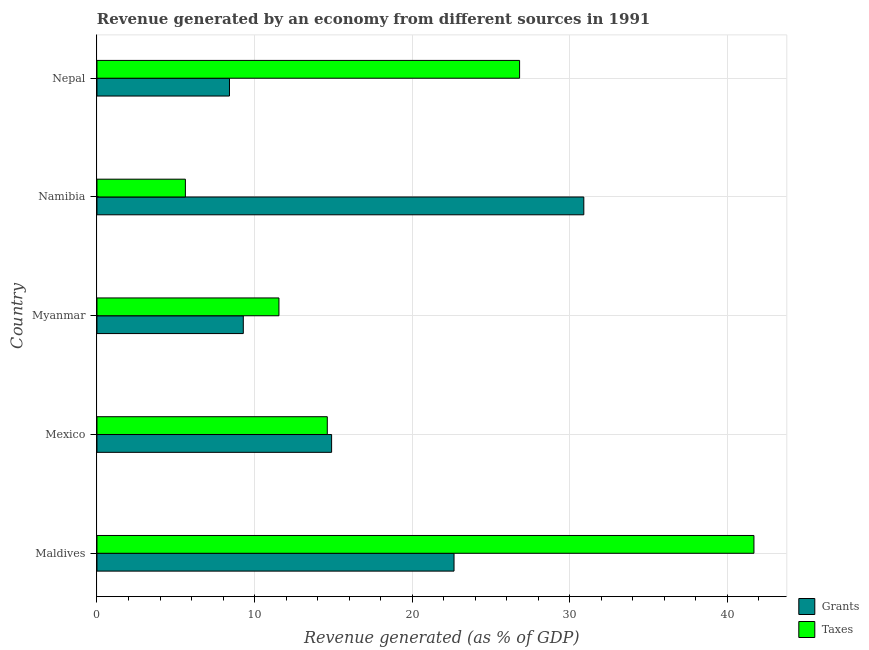How many different coloured bars are there?
Provide a succinct answer. 2. How many groups of bars are there?
Give a very brief answer. 5. How many bars are there on the 5th tick from the bottom?
Provide a succinct answer. 2. What is the label of the 1st group of bars from the top?
Make the answer very short. Nepal. What is the revenue generated by grants in Maldives?
Offer a terse response. 22.66. Across all countries, what is the maximum revenue generated by grants?
Your answer should be compact. 30.89. Across all countries, what is the minimum revenue generated by taxes?
Your response must be concise. 5.61. In which country was the revenue generated by grants maximum?
Offer a terse response. Namibia. In which country was the revenue generated by grants minimum?
Provide a short and direct response. Nepal. What is the total revenue generated by taxes in the graph?
Keep it short and to the point. 100.27. What is the difference between the revenue generated by taxes in Mexico and that in Namibia?
Provide a succinct answer. 9. What is the difference between the revenue generated by taxes in Mexico and the revenue generated by grants in Namibia?
Your response must be concise. -16.28. What is the average revenue generated by grants per country?
Your answer should be compact. 17.23. What is the difference between the revenue generated by taxes and revenue generated by grants in Myanmar?
Provide a succinct answer. 2.26. What is the ratio of the revenue generated by grants in Maldives to that in Myanmar?
Give a very brief answer. 2.44. What is the difference between the highest and the second highest revenue generated by grants?
Provide a succinct answer. 8.23. What is the difference between the highest and the lowest revenue generated by taxes?
Offer a very short reply. 36.07. In how many countries, is the revenue generated by grants greater than the average revenue generated by grants taken over all countries?
Offer a very short reply. 2. What does the 1st bar from the top in Mexico represents?
Make the answer very short. Taxes. What does the 2nd bar from the bottom in Mexico represents?
Give a very brief answer. Taxes. Are all the bars in the graph horizontal?
Offer a terse response. Yes. Does the graph contain grids?
Your answer should be very brief. Yes. How many legend labels are there?
Give a very brief answer. 2. What is the title of the graph?
Your response must be concise. Revenue generated by an economy from different sources in 1991. Does "Males" appear as one of the legend labels in the graph?
Keep it short and to the point. No. What is the label or title of the X-axis?
Offer a terse response. Revenue generated (as % of GDP). What is the label or title of the Y-axis?
Your response must be concise. Country. What is the Revenue generated (as % of GDP) of Grants in Maldives?
Your answer should be very brief. 22.66. What is the Revenue generated (as % of GDP) in Taxes in Maldives?
Provide a succinct answer. 41.68. What is the Revenue generated (as % of GDP) of Grants in Mexico?
Provide a succinct answer. 14.89. What is the Revenue generated (as % of GDP) of Taxes in Mexico?
Ensure brevity in your answer.  14.61. What is the Revenue generated (as % of GDP) in Grants in Myanmar?
Keep it short and to the point. 9.28. What is the Revenue generated (as % of GDP) in Taxes in Myanmar?
Your answer should be compact. 11.55. What is the Revenue generated (as % of GDP) in Grants in Namibia?
Your answer should be compact. 30.89. What is the Revenue generated (as % of GDP) of Taxes in Namibia?
Your response must be concise. 5.61. What is the Revenue generated (as % of GDP) in Grants in Nepal?
Keep it short and to the point. 8.41. What is the Revenue generated (as % of GDP) in Taxes in Nepal?
Ensure brevity in your answer.  26.82. Across all countries, what is the maximum Revenue generated (as % of GDP) of Grants?
Offer a very short reply. 30.89. Across all countries, what is the maximum Revenue generated (as % of GDP) of Taxes?
Provide a succinct answer. 41.68. Across all countries, what is the minimum Revenue generated (as % of GDP) of Grants?
Offer a terse response. 8.41. Across all countries, what is the minimum Revenue generated (as % of GDP) of Taxes?
Provide a short and direct response. 5.61. What is the total Revenue generated (as % of GDP) in Grants in the graph?
Provide a succinct answer. 86.13. What is the total Revenue generated (as % of GDP) in Taxes in the graph?
Offer a terse response. 100.27. What is the difference between the Revenue generated (as % of GDP) in Grants in Maldives and that in Mexico?
Keep it short and to the point. 7.77. What is the difference between the Revenue generated (as % of GDP) of Taxes in Maldives and that in Mexico?
Keep it short and to the point. 27.07. What is the difference between the Revenue generated (as % of GDP) of Grants in Maldives and that in Myanmar?
Offer a terse response. 13.37. What is the difference between the Revenue generated (as % of GDP) in Taxes in Maldives and that in Myanmar?
Provide a succinct answer. 30.14. What is the difference between the Revenue generated (as % of GDP) in Grants in Maldives and that in Namibia?
Make the answer very short. -8.23. What is the difference between the Revenue generated (as % of GDP) of Taxes in Maldives and that in Namibia?
Your answer should be compact. 36.07. What is the difference between the Revenue generated (as % of GDP) of Grants in Maldives and that in Nepal?
Your answer should be compact. 14.25. What is the difference between the Revenue generated (as % of GDP) of Taxes in Maldives and that in Nepal?
Offer a terse response. 14.87. What is the difference between the Revenue generated (as % of GDP) of Grants in Mexico and that in Myanmar?
Your answer should be very brief. 5.6. What is the difference between the Revenue generated (as % of GDP) of Taxes in Mexico and that in Myanmar?
Make the answer very short. 3.07. What is the difference between the Revenue generated (as % of GDP) of Grants in Mexico and that in Namibia?
Keep it short and to the point. -16. What is the difference between the Revenue generated (as % of GDP) in Taxes in Mexico and that in Namibia?
Your answer should be very brief. 9. What is the difference between the Revenue generated (as % of GDP) of Grants in Mexico and that in Nepal?
Give a very brief answer. 6.48. What is the difference between the Revenue generated (as % of GDP) of Taxes in Mexico and that in Nepal?
Offer a terse response. -12.2. What is the difference between the Revenue generated (as % of GDP) in Grants in Myanmar and that in Namibia?
Ensure brevity in your answer.  -21.61. What is the difference between the Revenue generated (as % of GDP) of Taxes in Myanmar and that in Namibia?
Ensure brevity in your answer.  5.94. What is the difference between the Revenue generated (as % of GDP) in Grants in Myanmar and that in Nepal?
Offer a terse response. 0.88. What is the difference between the Revenue generated (as % of GDP) of Taxes in Myanmar and that in Nepal?
Offer a very short reply. -15.27. What is the difference between the Revenue generated (as % of GDP) of Grants in Namibia and that in Nepal?
Provide a short and direct response. 22.48. What is the difference between the Revenue generated (as % of GDP) of Taxes in Namibia and that in Nepal?
Offer a very short reply. -21.21. What is the difference between the Revenue generated (as % of GDP) in Grants in Maldives and the Revenue generated (as % of GDP) in Taxes in Mexico?
Offer a terse response. 8.04. What is the difference between the Revenue generated (as % of GDP) in Grants in Maldives and the Revenue generated (as % of GDP) in Taxes in Myanmar?
Your answer should be very brief. 11.11. What is the difference between the Revenue generated (as % of GDP) in Grants in Maldives and the Revenue generated (as % of GDP) in Taxes in Namibia?
Offer a very short reply. 17.05. What is the difference between the Revenue generated (as % of GDP) in Grants in Maldives and the Revenue generated (as % of GDP) in Taxes in Nepal?
Provide a succinct answer. -4.16. What is the difference between the Revenue generated (as % of GDP) in Grants in Mexico and the Revenue generated (as % of GDP) in Taxes in Myanmar?
Keep it short and to the point. 3.34. What is the difference between the Revenue generated (as % of GDP) of Grants in Mexico and the Revenue generated (as % of GDP) of Taxes in Namibia?
Provide a succinct answer. 9.28. What is the difference between the Revenue generated (as % of GDP) in Grants in Mexico and the Revenue generated (as % of GDP) in Taxes in Nepal?
Provide a short and direct response. -11.93. What is the difference between the Revenue generated (as % of GDP) of Grants in Myanmar and the Revenue generated (as % of GDP) of Taxes in Namibia?
Make the answer very short. 3.67. What is the difference between the Revenue generated (as % of GDP) in Grants in Myanmar and the Revenue generated (as % of GDP) in Taxes in Nepal?
Give a very brief answer. -17.53. What is the difference between the Revenue generated (as % of GDP) in Grants in Namibia and the Revenue generated (as % of GDP) in Taxes in Nepal?
Provide a succinct answer. 4.08. What is the average Revenue generated (as % of GDP) of Grants per country?
Make the answer very short. 17.23. What is the average Revenue generated (as % of GDP) in Taxes per country?
Your response must be concise. 20.05. What is the difference between the Revenue generated (as % of GDP) of Grants and Revenue generated (as % of GDP) of Taxes in Maldives?
Ensure brevity in your answer.  -19.03. What is the difference between the Revenue generated (as % of GDP) in Grants and Revenue generated (as % of GDP) in Taxes in Mexico?
Your answer should be very brief. 0.27. What is the difference between the Revenue generated (as % of GDP) in Grants and Revenue generated (as % of GDP) in Taxes in Myanmar?
Keep it short and to the point. -2.26. What is the difference between the Revenue generated (as % of GDP) in Grants and Revenue generated (as % of GDP) in Taxes in Namibia?
Your response must be concise. 25.28. What is the difference between the Revenue generated (as % of GDP) in Grants and Revenue generated (as % of GDP) in Taxes in Nepal?
Your answer should be very brief. -18.41. What is the ratio of the Revenue generated (as % of GDP) of Grants in Maldives to that in Mexico?
Offer a very short reply. 1.52. What is the ratio of the Revenue generated (as % of GDP) in Taxes in Maldives to that in Mexico?
Your answer should be very brief. 2.85. What is the ratio of the Revenue generated (as % of GDP) of Grants in Maldives to that in Myanmar?
Offer a very short reply. 2.44. What is the ratio of the Revenue generated (as % of GDP) in Taxes in Maldives to that in Myanmar?
Your response must be concise. 3.61. What is the ratio of the Revenue generated (as % of GDP) of Grants in Maldives to that in Namibia?
Ensure brevity in your answer.  0.73. What is the ratio of the Revenue generated (as % of GDP) of Taxes in Maldives to that in Namibia?
Provide a succinct answer. 7.43. What is the ratio of the Revenue generated (as % of GDP) of Grants in Maldives to that in Nepal?
Your response must be concise. 2.69. What is the ratio of the Revenue generated (as % of GDP) of Taxes in Maldives to that in Nepal?
Your answer should be very brief. 1.55. What is the ratio of the Revenue generated (as % of GDP) in Grants in Mexico to that in Myanmar?
Provide a succinct answer. 1.6. What is the ratio of the Revenue generated (as % of GDP) of Taxes in Mexico to that in Myanmar?
Provide a succinct answer. 1.27. What is the ratio of the Revenue generated (as % of GDP) of Grants in Mexico to that in Namibia?
Offer a terse response. 0.48. What is the ratio of the Revenue generated (as % of GDP) of Taxes in Mexico to that in Namibia?
Your answer should be very brief. 2.6. What is the ratio of the Revenue generated (as % of GDP) of Grants in Mexico to that in Nepal?
Make the answer very short. 1.77. What is the ratio of the Revenue generated (as % of GDP) in Taxes in Mexico to that in Nepal?
Give a very brief answer. 0.55. What is the ratio of the Revenue generated (as % of GDP) of Grants in Myanmar to that in Namibia?
Provide a short and direct response. 0.3. What is the ratio of the Revenue generated (as % of GDP) of Taxes in Myanmar to that in Namibia?
Your answer should be compact. 2.06. What is the ratio of the Revenue generated (as % of GDP) of Grants in Myanmar to that in Nepal?
Offer a very short reply. 1.1. What is the ratio of the Revenue generated (as % of GDP) of Taxes in Myanmar to that in Nepal?
Your answer should be compact. 0.43. What is the ratio of the Revenue generated (as % of GDP) of Grants in Namibia to that in Nepal?
Your answer should be compact. 3.67. What is the ratio of the Revenue generated (as % of GDP) in Taxes in Namibia to that in Nepal?
Make the answer very short. 0.21. What is the difference between the highest and the second highest Revenue generated (as % of GDP) in Grants?
Your answer should be very brief. 8.23. What is the difference between the highest and the second highest Revenue generated (as % of GDP) in Taxes?
Give a very brief answer. 14.87. What is the difference between the highest and the lowest Revenue generated (as % of GDP) of Grants?
Offer a very short reply. 22.48. What is the difference between the highest and the lowest Revenue generated (as % of GDP) in Taxes?
Give a very brief answer. 36.07. 